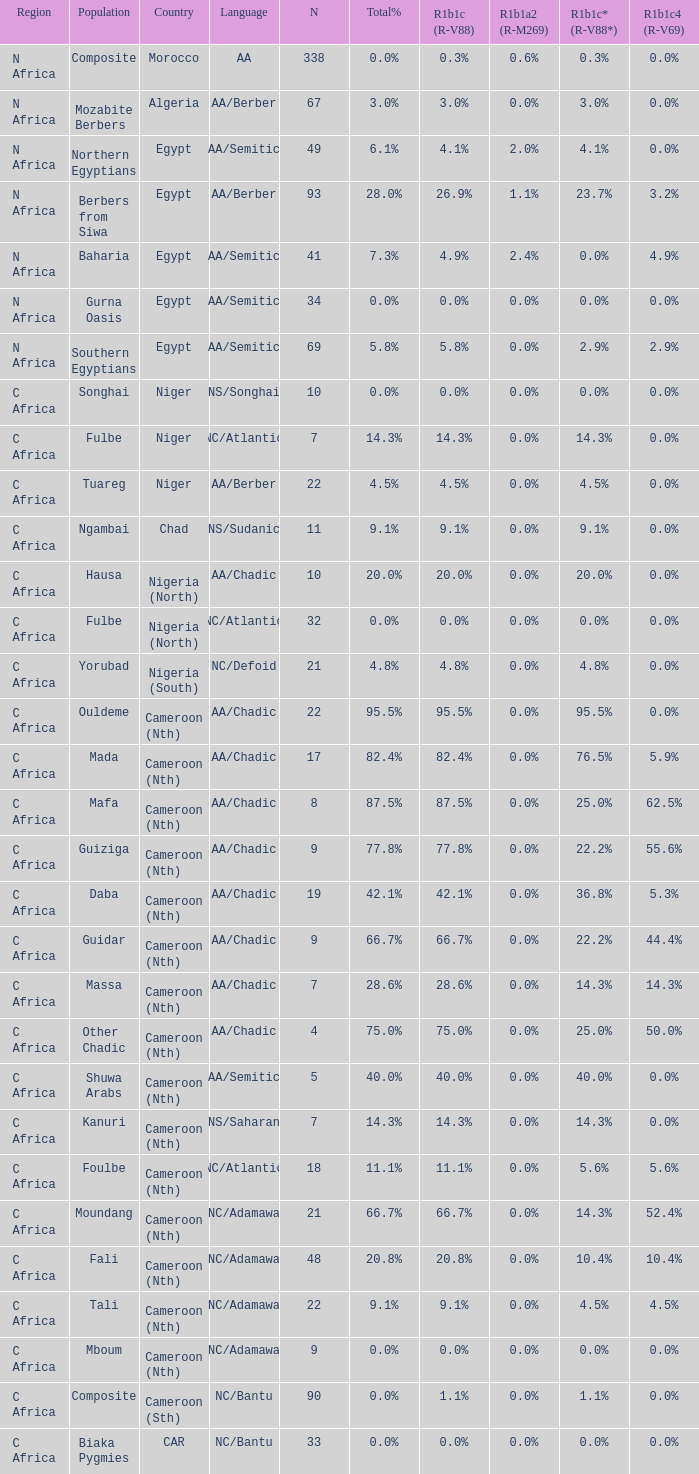What is the number of n mentioned for 0.6% r1b1a2 (r-m269)? 1.0. 